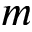<formula> <loc_0><loc_0><loc_500><loc_500>m</formula> 